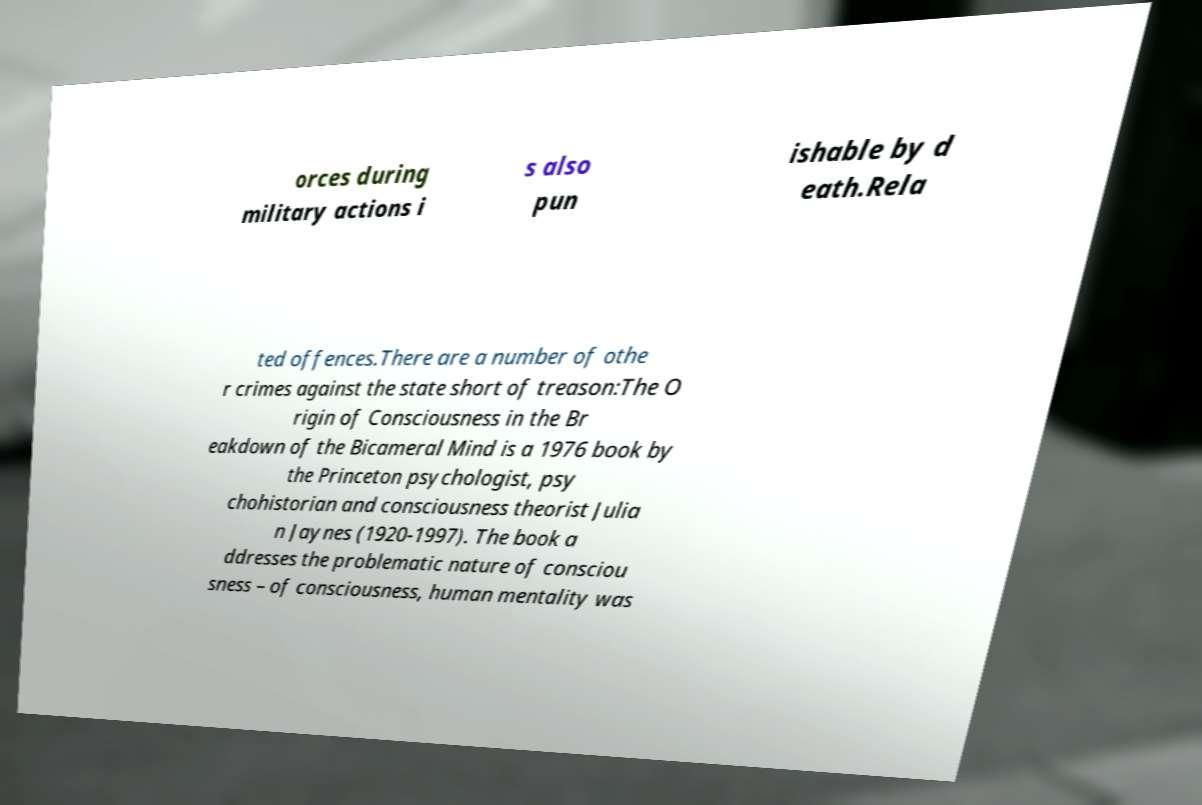I need the written content from this picture converted into text. Can you do that? orces during military actions i s also pun ishable by d eath.Rela ted offences.There are a number of othe r crimes against the state short of treason:The O rigin of Consciousness in the Br eakdown of the Bicameral Mind is a 1976 book by the Princeton psychologist, psy chohistorian and consciousness theorist Julia n Jaynes (1920-1997). The book a ddresses the problematic nature of consciou sness – of consciousness, human mentality was 